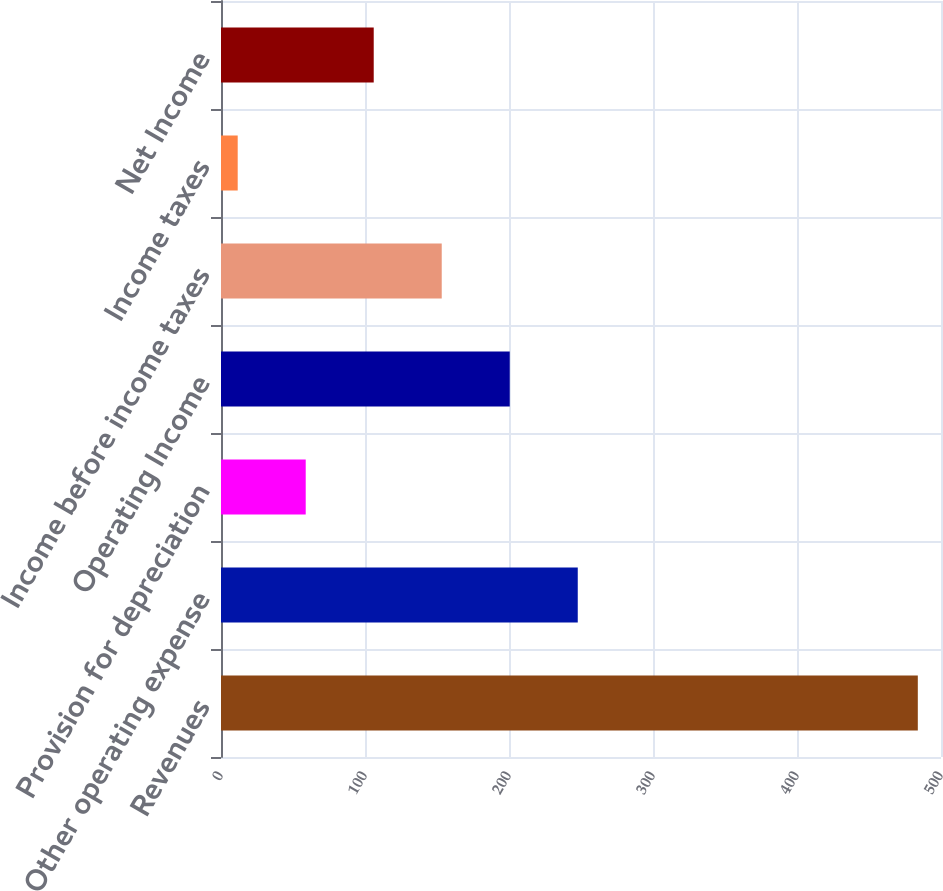Convert chart. <chart><loc_0><loc_0><loc_500><loc_500><bar_chart><fcel>Revenues<fcel>Other operating expense<fcel>Provision for depreciation<fcel>Operating Income<fcel>Income before income taxes<fcel>Income taxes<fcel>Net Income<nl><fcel>483.9<fcel>247.75<fcel>58.83<fcel>200.52<fcel>153.29<fcel>11.6<fcel>106.06<nl></chart> 